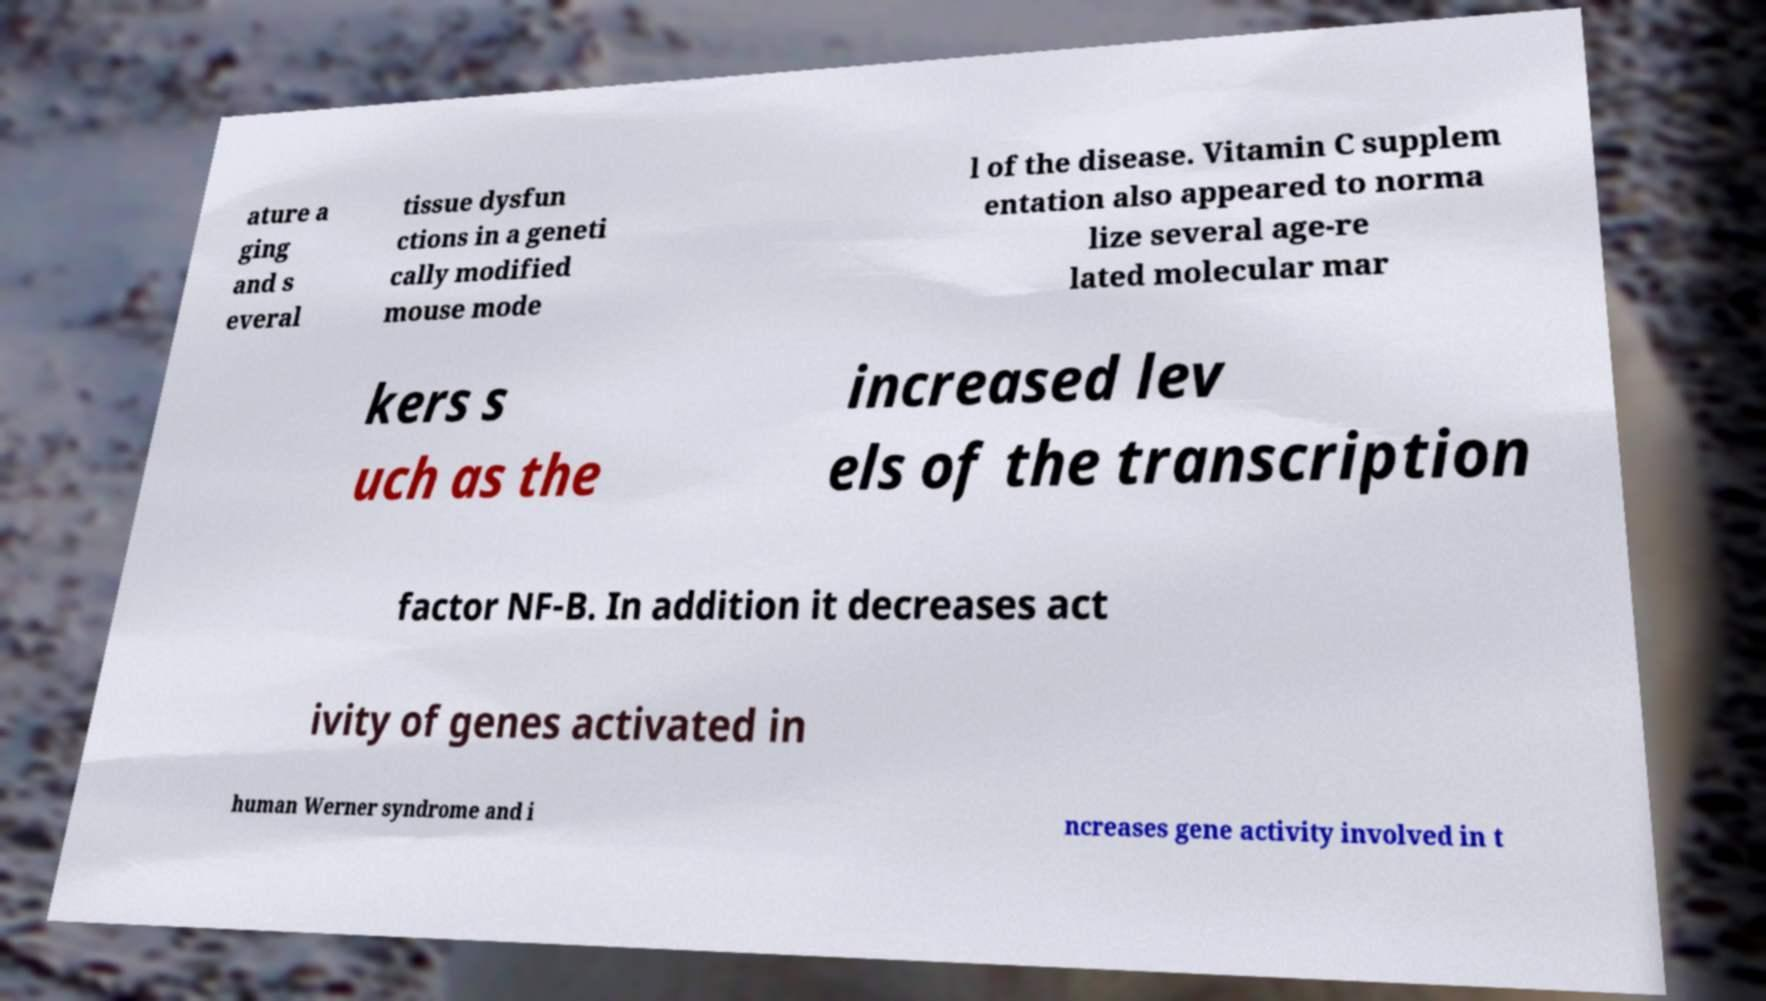For documentation purposes, I need the text within this image transcribed. Could you provide that? ature a ging and s everal tissue dysfun ctions in a geneti cally modified mouse mode l of the disease. Vitamin C supplem entation also appeared to norma lize several age-re lated molecular mar kers s uch as the increased lev els of the transcription factor NF-B. In addition it decreases act ivity of genes activated in human Werner syndrome and i ncreases gene activity involved in t 